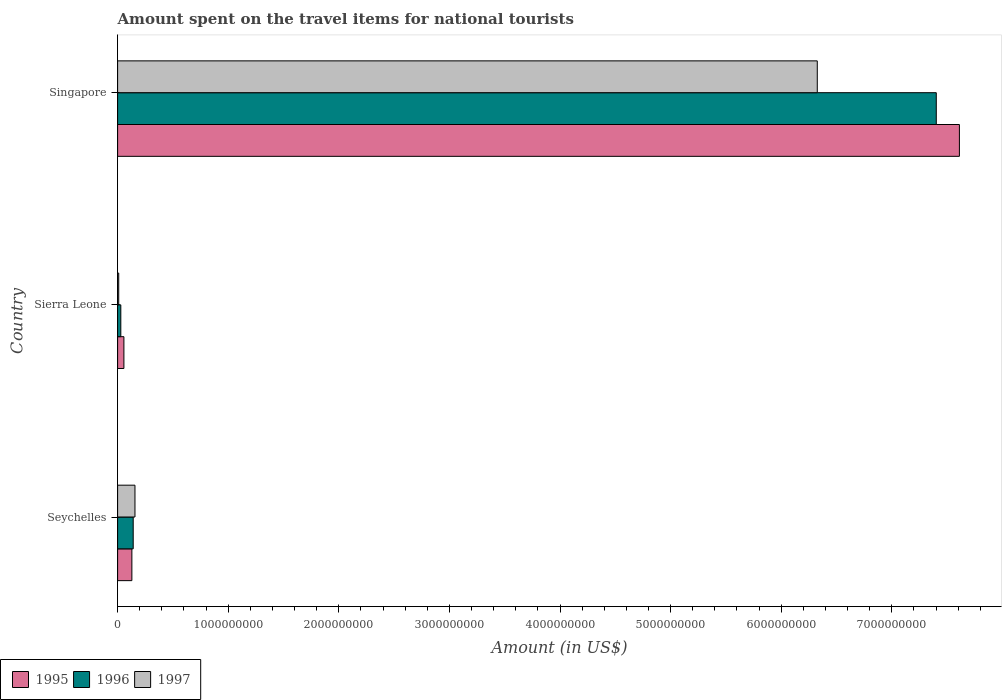How many groups of bars are there?
Offer a very short reply. 3. How many bars are there on the 2nd tick from the bottom?
Your answer should be very brief. 3. What is the label of the 1st group of bars from the top?
Give a very brief answer. Singapore. What is the amount spent on the travel items for national tourists in 1996 in Seychelles?
Your response must be concise. 1.41e+08. Across all countries, what is the maximum amount spent on the travel items for national tourists in 1997?
Provide a short and direct response. 6.33e+09. Across all countries, what is the minimum amount spent on the travel items for national tourists in 1996?
Give a very brief answer. 2.90e+07. In which country was the amount spent on the travel items for national tourists in 1996 maximum?
Keep it short and to the point. Singapore. In which country was the amount spent on the travel items for national tourists in 1997 minimum?
Give a very brief answer. Sierra Leone. What is the total amount spent on the travel items for national tourists in 1996 in the graph?
Provide a short and direct response. 7.57e+09. What is the difference between the amount spent on the travel items for national tourists in 1997 in Seychelles and that in Singapore?
Provide a short and direct response. -6.17e+09. What is the difference between the amount spent on the travel items for national tourists in 1996 in Sierra Leone and the amount spent on the travel items for national tourists in 1997 in Singapore?
Offer a very short reply. -6.30e+09. What is the average amount spent on the travel items for national tourists in 1996 per country?
Offer a terse response. 2.52e+09. What is the difference between the amount spent on the travel items for national tourists in 1997 and amount spent on the travel items for national tourists in 1996 in Seychelles?
Your response must be concise. 1.60e+07. In how many countries, is the amount spent on the travel items for national tourists in 1995 greater than 400000000 US$?
Offer a very short reply. 1. What is the ratio of the amount spent on the travel items for national tourists in 1997 in Sierra Leone to that in Singapore?
Give a very brief answer. 0. Is the amount spent on the travel items for national tourists in 1996 in Sierra Leone less than that in Singapore?
Ensure brevity in your answer.  Yes. What is the difference between the highest and the second highest amount spent on the travel items for national tourists in 1995?
Offer a terse response. 7.48e+09. What is the difference between the highest and the lowest amount spent on the travel items for national tourists in 1995?
Give a very brief answer. 7.55e+09. What does the 2nd bar from the top in Singapore represents?
Your answer should be compact. 1996. How many countries are there in the graph?
Provide a succinct answer. 3. What is the difference between two consecutive major ticks on the X-axis?
Provide a short and direct response. 1.00e+09. Does the graph contain any zero values?
Provide a succinct answer. No. Does the graph contain grids?
Provide a succinct answer. No. Where does the legend appear in the graph?
Ensure brevity in your answer.  Bottom left. How many legend labels are there?
Provide a short and direct response. 3. How are the legend labels stacked?
Provide a short and direct response. Horizontal. What is the title of the graph?
Provide a succinct answer. Amount spent on the travel items for national tourists. What is the Amount (in US$) of 1995 in Seychelles?
Provide a succinct answer. 1.29e+08. What is the Amount (in US$) of 1996 in Seychelles?
Your answer should be compact. 1.41e+08. What is the Amount (in US$) in 1997 in Seychelles?
Give a very brief answer. 1.57e+08. What is the Amount (in US$) of 1995 in Sierra Leone?
Ensure brevity in your answer.  5.70e+07. What is the Amount (in US$) in 1996 in Sierra Leone?
Give a very brief answer. 2.90e+07. What is the Amount (in US$) in 1995 in Singapore?
Keep it short and to the point. 7.61e+09. What is the Amount (in US$) of 1996 in Singapore?
Your response must be concise. 7.40e+09. What is the Amount (in US$) in 1997 in Singapore?
Your response must be concise. 6.33e+09. Across all countries, what is the maximum Amount (in US$) of 1995?
Keep it short and to the point. 7.61e+09. Across all countries, what is the maximum Amount (in US$) of 1996?
Ensure brevity in your answer.  7.40e+09. Across all countries, what is the maximum Amount (in US$) in 1997?
Your response must be concise. 6.33e+09. Across all countries, what is the minimum Amount (in US$) in 1995?
Your answer should be very brief. 5.70e+07. Across all countries, what is the minimum Amount (in US$) of 1996?
Offer a very short reply. 2.90e+07. What is the total Amount (in US$) in 1995 in the graph?
Make the answer very short. 7.80e+09. What is the total Amount (in US$) of 1996 in the graph?
Your answer should be compact. 7.57e+09. What is the total Amount (in US$) in 1997 in the graph?
Offer a very short reply. 6.49e+09. What is the difference between the Amount (in US$) of 1995 in Seychelles and that in Sierra Leone?
Give a very brief answer. 7.20e+07. What is the difference between the Amount (in US$) in 1996 in Seychelles and that in Sierra Leone?
Your answer should be compact. 1.12e+08. What is the difference between the Amount (in US$) of 1997 in Seychelles and that in Sierra Leone?
Your response must be concise. 1.47e+08. What is the difference between the Amount (in US$) of 1995 in Seychelles and that in Singapore?
Ensure brevity in your answer.  -7.48e+09. What is the difference between the Amount (in US$) in 1996 in Seychelles and that in Singapore?
Provide a succinct answer. -7.26e+09. What is the difference between the Amount (in US$) of 1997 in Seychelles and that in Singapore?
Provide a succinct answer. -6.17e+09. What is the difference between the Amount (in US$) of 1995 in Sierra Leone and that in Singapore?
Make the answer very short. -7.55e+09. What is the difference between the Amount (in US$) in 1996 in Sierra Leone and that in Singapore?
Give a very brief answer. -7.37e+09. What is the difference between the Amount (in US$) in 1997 in Sierra Leone and that in Singapore?
Offer a terse response. -6.32e+09. What is the difference between the Amount (in US$) of 1995 in Seychelles and the Amount (in US$) of 1997 in Sierra Leone?
Offer a terse response. 1.19e+08. What is the difference between the Amount (in US$) in 1996 in Seychelles and the Amount (in US$) in 1997 in Sierra Leone?
Make the answer very short. 1.31e+08. What is the difference between the Amount (in US$) in 1995 in Seychelles and the Amount (in US$) in 1996 in Singapore?
Keep it short and to the point. -7.27e+09. What is the difference between the Amount (in US$) in 1995 in Seychelles and the Amount (in US$) in 1997 in Singapore?
Your answer should be compact. -6.20e+09. What is the difference between the Amount (in US$) in 1996 in Seychelles and the Amount (in US$) in 1997 in Singapore?
Keep it short and to the point. -6.18e+09. What is the difference between the Amount (in US$) in 1995 in Sierra Leone and the Amount (in US$) in 1996 in Singapore?
Offer a terse response. -7.34e+09. What is the difference between the Amount (in US$) in 1995 in Sierra Leone and the Amount (in US$) in 1997 in Singapore?
Provide a short and direct response. -6.27e+09. What is the difference between the Amount (in US$) of 1996 in Sierra Leone and the Amount (in US$) of 1997 in Singapore?
Make the answer very short. -6.30e+09. What is the average Amount (in US$) in 1995 per country?
Your answer should be very brief. 2.60e+09. What is the average Amount (in US$) in 1996 per country?
Your answer should be compact. 2.52e+09. What is the average Amount (in US$) in 1997 per country?
Your response must be concise. 2.16e+09. What is the difference between the Amount (in US$) in 1995 and Amount (in US$) in 1996 in Seychelles?
Offer a terse response. -1.20e+07. What is the difference between the Amount (in US$) of 1995 and Amount (in US$) of 1997 in Seychelles?
Offer a very short reply. -2.80e+07. What is the difference between the Amount (in US$) in 1996 and Amount (in US$) in 1997 in Seychelles?
Provide a short and direct response. -1.60e+07. What is the difference between the Amount (in US$) of 1995 and Amount (in US$) of 1996 in Sierra Leone?
Your answer should be very brief. 2.80e+07. What is the difference between the Amount (in US$) in 1995 and Amount (in US$) in 1997 in Sierra Leone?
Offer a terse response. 4.70e+07. What is the difference between the Amount (in US$) in 1996 and Amount (in US$) in 1997 in Sierra Leone?
Make the answer very short. 1.90e+07. What is the difference between the Amount (in US$) in 1995 and Amount (in US$) in 1996 in Singapore?
Keep it short and to the point. 2.09e+08. What is the difference between the Amount (in US$) in 1995 and Amount (in US$) in 1997 in Singapore?
Make the answer very short. 1.28e+09. What is the difference between the Amount (in US$) of 1996 and Amount (in US$) of 1997 in Singapore?
Offer a terse response. 1.08e+09. What is the ratio of the Amount (in US$) in 1995 in Seychelles to that in Sierra Leone?
Give a very brief answer. 2.26. What is the ratio of the Amount (in US$) in 1996 in Seychelles to that in Sierra Leone?
Provide a succinct answer. 4.86. What is the ratio of the Amount (in US$) in 1995 in Seychelles to that in Singapore?
Your response must be concise. 0.02. What is the ratio of the Amount (in US$) in 1996 in Seychelles to that in Singapore?
Ensure brevity in your answer.  0.02. What is the ratio of the Amount (in US$) in 1997 in Seychelles to that in Singapore?
Provide a short and direct response. 0.02. What is the ratio of the Amount (in US$) in 1995 in Sierra Leone to that in Singapore?
Keep it short and to the point. 0.01. What is the ratio of the Amount (in US$) in 1996 in Sierra Leone to that in Singapore?
Your answer should be very brief. 0. What is the ratio of the Amount (in US$) of 1997 in Sierra Leone to that in Singapore?
Offer a terse response. 0. What is the difference between the highest and the second highest Amount (in US$) of 1995?
Your answer should be very brief. 7.48e+09. What is the difference between the highest and the second highest Amount (in US$) of 1996?
Offer a very short reply. 7.26e+09. What is the difference between the highest and the second highest Amount (in US$) in 1997?
Your answer should be very brief. 6.17e+09. What is the difference between the highest and the lowest Amount (in US$) of 1995?
Your answer should be very brief. 7.55e+09. What is the difference between the highest and the lowest Amount (in US$) of 1996?
Your answer should be compact. 7.37e+09. What is the difference between the highest and the lowest Amount (in US$) of 1997?
Ensure brevity in your answer.  6.32e+09. 